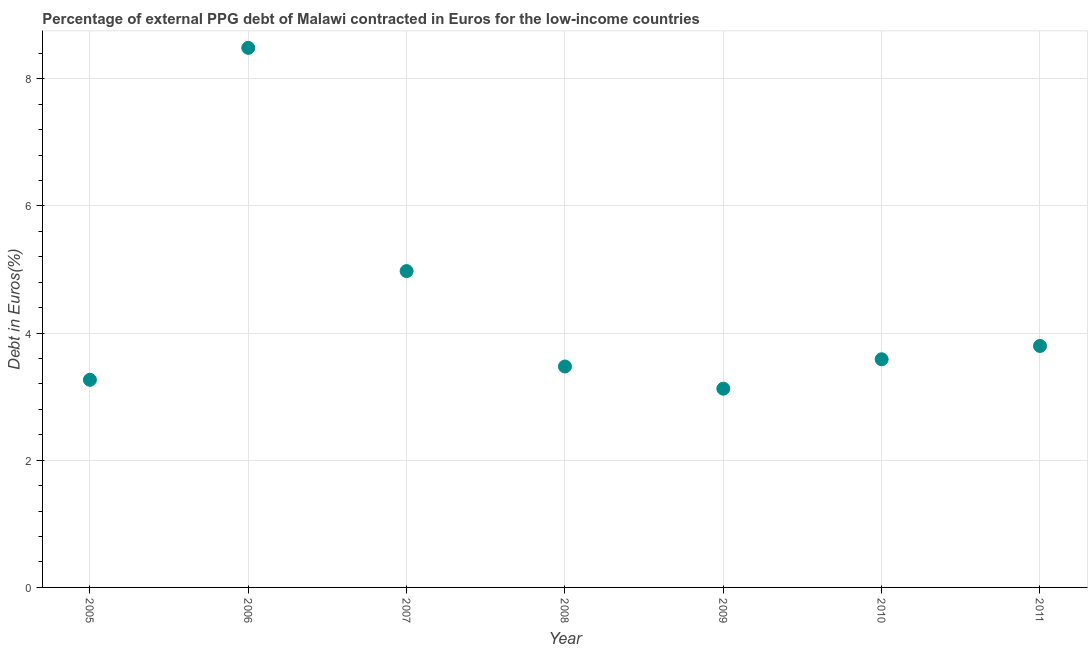What is the currency composition of ppg debt in 2008?
Provide a succinct answer. 3.47. Across all years, what is the maximum currency composition of ppg debt?
Provide a short and direct response. 8.49. Across all years, what is the minimum currency composition of ppg debt?
Provide a short and direct response. 3.13. In which year was the currency composition of ppg debt maximum?
Your response must be concise. 2006. In which year was the currency composition of ppg debt minimum?
Provide a succinct answer. 2009. What is the sum of the currency composition of ppg debt?
Make the answer very short. 30.71. What is the difference between the currency composition of ppg debt in 2007 and 2010?
Provide a short and direct response. 1.39. What is the average currency composition of ppg debt per year?
Your response must be concise. 4.39. What is the median currency composition of ppg debt?
Make the answer very short. 3.59. In how many years, is the currency composition of ppg debt greater than 4.8 %?
Your response must be concise. 2. Do a majority of the years between 2011 and 2008 (inclusive) have currency composition of ppg debt greater than 1.6 %?
Offer a very short reply. Yes. What is the ratio of the currency composition of ppg debt in 2009 to that in 2011?
Your response must be concise. 0.82. Is the currency composition of ppg debt in 2007 less than that in 2010?
Give a very brief answer. No. What is the difference between the highest and the second highest currency composition of ppg debt?
Your answer should be compact. 3.51. Is the sum of the currency composition of ppg debt in 2007 and 2008 greater than the maximum currency composition of ppg debt across all years?
Offer a very short reply. No. What is the difference between the highest and the lowest currency composition of ppg debt?
Your answer should be compact. 5.36. Are the values on the major ticks of Y-axis written in scientific E-notation?
Provide a succinct answer. No. Does the graph contain grids?
Give a very brief answer. Yes. What is the title of the graph?
Offer a very short reply. Percentage of external PPG debt of Malawi contracted in Euros for the low-income countries. What is the label or title of the X-axis?
Give a very brief answer. Year. What is the label or title of the Y-axis?
Ensure brevity in your answer.  Debt in Euros(%). What is the Debt in Euros(%) in 2005?
Ensure brevity in your answer.  3.27. What is the Debt in Euros(%) in 2006?
Offer a terse response. 8.49. What is the Debt in Euros(%) in 2007?
Provide a succinct answer. 4.98. What is the Debt in Euros(%) in 2008?
Offer a terse response. 3.47. What is the Debt in Euros(%) in 2009?
Offer a very short reply. 3.13. What is the Debt in Euros(%) in 2010?
Offer a terse response. 3.59. What is the Debt in Euros(%) in 2011?
Offer a very short reply. 3.8. What is the difference between the Debt in Euros(%) in 2005 and 2006?
Your response must be concise. -5.22. What is the difference between the Debt in Euros(%) in 2005 and 2007?
Your response must be concise. -1.71. What is the difference between the Debt in Euros(%) in 2005 and 2008?
Your answer should be very brief. -0.21. What is the difference between the Debt in Euros(%) in 2005 and 2009?
Make the answer very short. 0.14. What is the difference between the Debt in Euros(%) in 2005 and 2010?
Ensure brevity in your answer.  -0.32. What is the difference between the Debt in Euros(%) in 2005 and 2011?
Offer a very short reply. -0.53. What is the difference between the Debt in Euros(%) in 2006 and 2007?
Ensure brevity in your answer.  3.51. What is the difference between the Debt in Euros(%) in 2006 and 2008?
Provide a succinct answer. 5.01. What is the difference between the Debt in Euros(%) in 2006 and 2009?
Make the answer very short. 5.36. What is the difference between the Debt in Euros(%) in 2006 and 2010?
Your answer should be very brief. 4.9. What is the difference between the Debt in Euros(%) in 2006 and 2011?
Offer a terse response. 4.69. What is the difference between the Debt in Euros(%) in 2007 and 2008?
Keep it short and to the point. 1.5. What is the difference between the Debt in Euros(%) in 2007 and 2009?
Provide a short and direct response. 1.85. What is the difference between the Debt in Euros(%) in 2007 and 2010?
Offer a very short reply. 1.39. What is the difference between the Debt in Euros(%) in 2007 and 2011?
Make the answer very short. 1.18. What is the difference between the Debt in Euros(%) in 2008 and 2009?
Offer a terse response. 0.35. What is the difference between the Debt in Euros(%) in 2008 and 2010?
Your answer should be very brief. -0.11. What is the difference between the Debt in Euros(%) in 2008 and 2011?
Your answer should be very brief. -0.32. What is the difference between the Debt in Euros(%) in 2009 and 2010?
Give a very brief answer. -0.46. What is the difference between the Debt in Euros(%) in 2009 and 2011?
Your response must be concise. -0.67. What is the difference between the Debt in Euros(%) in 2010 and 2011?
Keep it short and to the point. -0.21. What is the ratio of the Debt in Euros(%) in 2005 to that in 2006?
Your answer should be very brief. 0.39. What is the ratio of the Debt in Euros(%) in 2005 to that in 2007?
Provide a short and direct response. 0.66. What is the ratio of the Debt in Euros(%) in 2005 to that in 2008?
Your response must be concise. 0.94. What is the ratio of the Debt in Euros(%) in 2005 to that in 2009?
Your response must be concise. 1.04. What is the ratio of the Debt in Euros(%) in 2005 to that in 2010?
Offer a terse response. 0.91. What is the ratio of the Debt in Euros(%) in 2005 to that in 2011?
Give a very brief answer. 0.86. What is the ratio of the Debt in Euros(%) in 2006 to that in 2007?
Your answer should be very brief. 1.71. What is the ratio of the Debt in Euros(%) in 2006 to that in 2008?
Your answer should be compact. 2.44. What is the ratio of the Debt in Euros(%) in 2006 to that in 2009?
Your answer should be very brief. 2.71. What is the ratio of the Debt in Euros(%) in 2006 to that in 2010?
Give a very brief answer. 2.37. What is the ratio of the Debt in Euros(%) in 2006 to that in 2011?
Your response must be concise. 2.23. What is the ratio of the Debt in Euros(%) in 2007 to that in 2008?
Your answer should be very brief. 1.43. What is the ratio of the Debt in Euros(%) in 2007 to that in 2009?
Make the answer very short. 1.59. What is the ratio of the Debt in Euros(%) in 2007 to that in 2010?
Your answer should be very brief. 1.39. What is the ratio of the Debt in Euros(%) in 2007 to that in 2011?
Provide a short and direct response. 1.31. What is the ratio of the Debt in Euros(%) in 2008 to that in 2009?
Your answer should be very brief. 1.11. What is the ratio of the Debt in Euros(%) in 2008 to that in 2011?
Give a very brief answer. 0.92. What is the ratio of the Debt in Euros(%) in 2009 to that in 2010?
Keep it short and to the point. 0.87. What is the ratio of the Debt in Euros(%) in 2009 to that in 2011?
Offer a terse response. 0.82. What is the ratio of the Debt in Euros(%) in 2010 to that in 2011?
Your response must be concise. 0.94. 